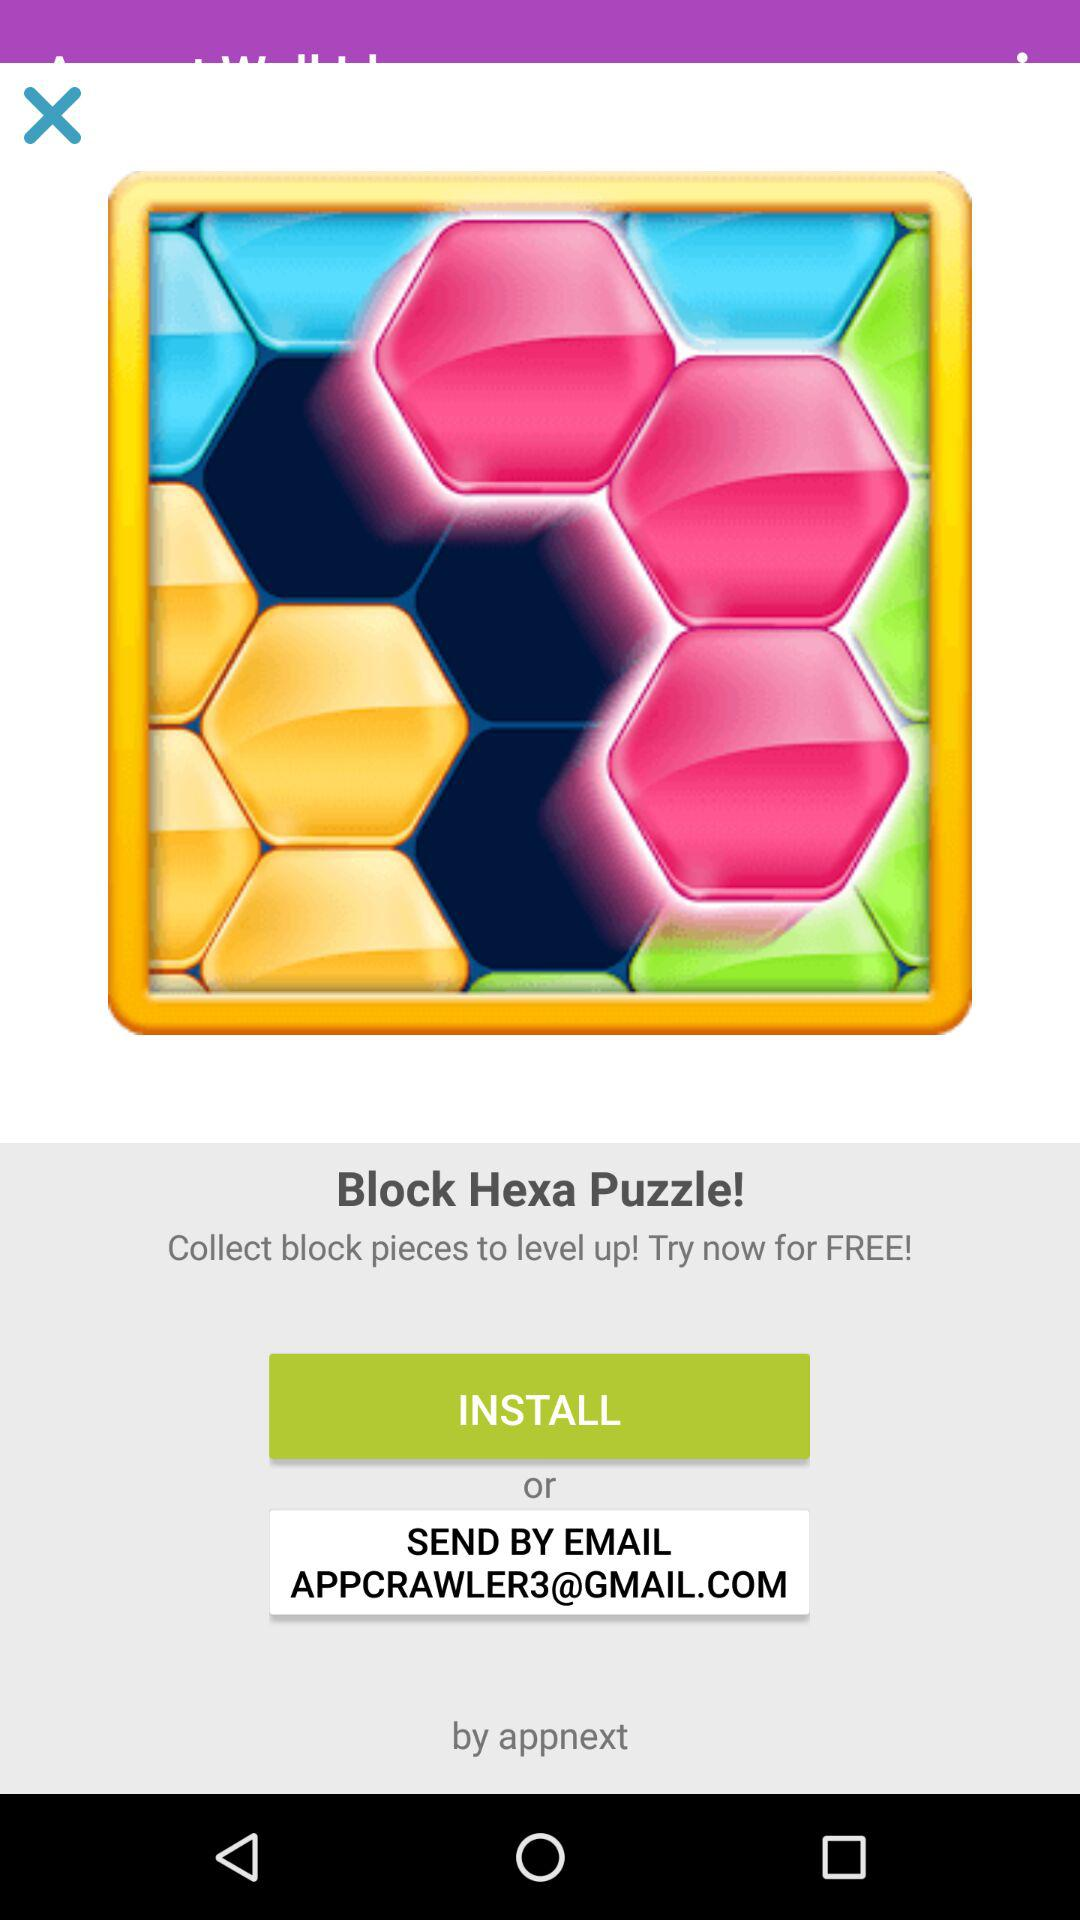What is the name of the game? The name of the game is "Block Hexa Puzzle!". 